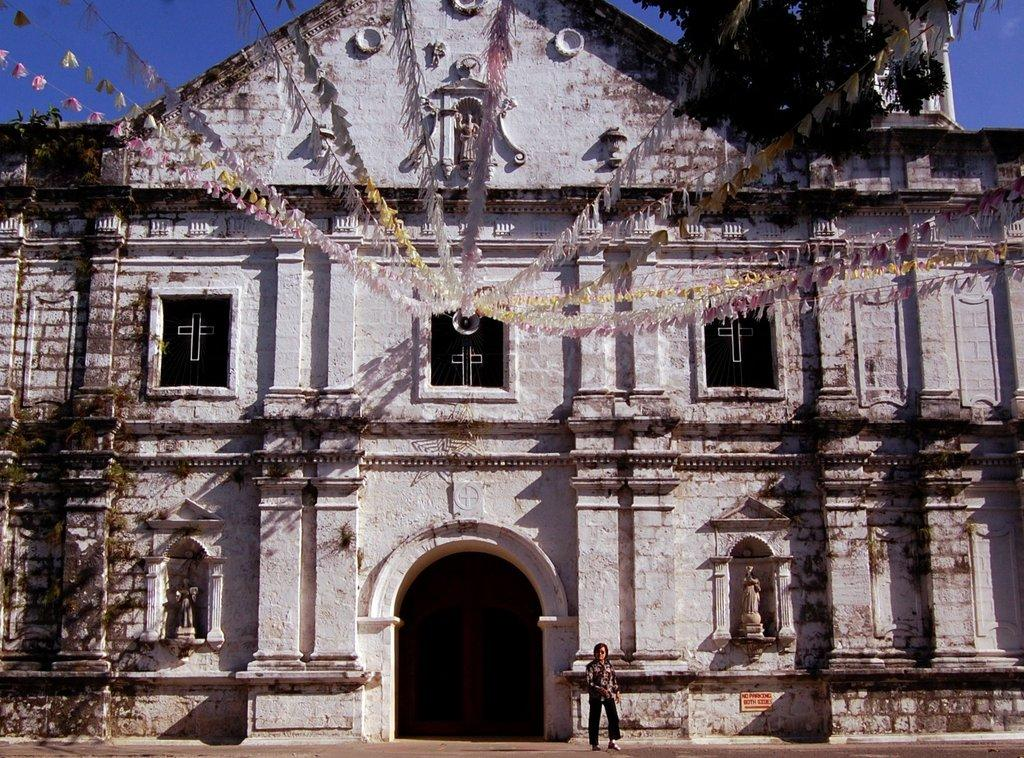Who is present in the image? There is a woman in the image. What type of artwork can be seen in the image? There are sculptures in the image. What national symbols are present in the image? There are flags in the image. What type of vegetation is visible in the image? There are trees in the image. What type of structure is visible in the image? There is a building in the image. What is visible in the background of the image? The sky is visible in the background of the image. What hobbies does the girl in the image enjoy? There is no girl present in the image, only a woman. What type of sport does the girl in the image play? There is no girl present in the image, so it is not possible to determine what sport she might play. 